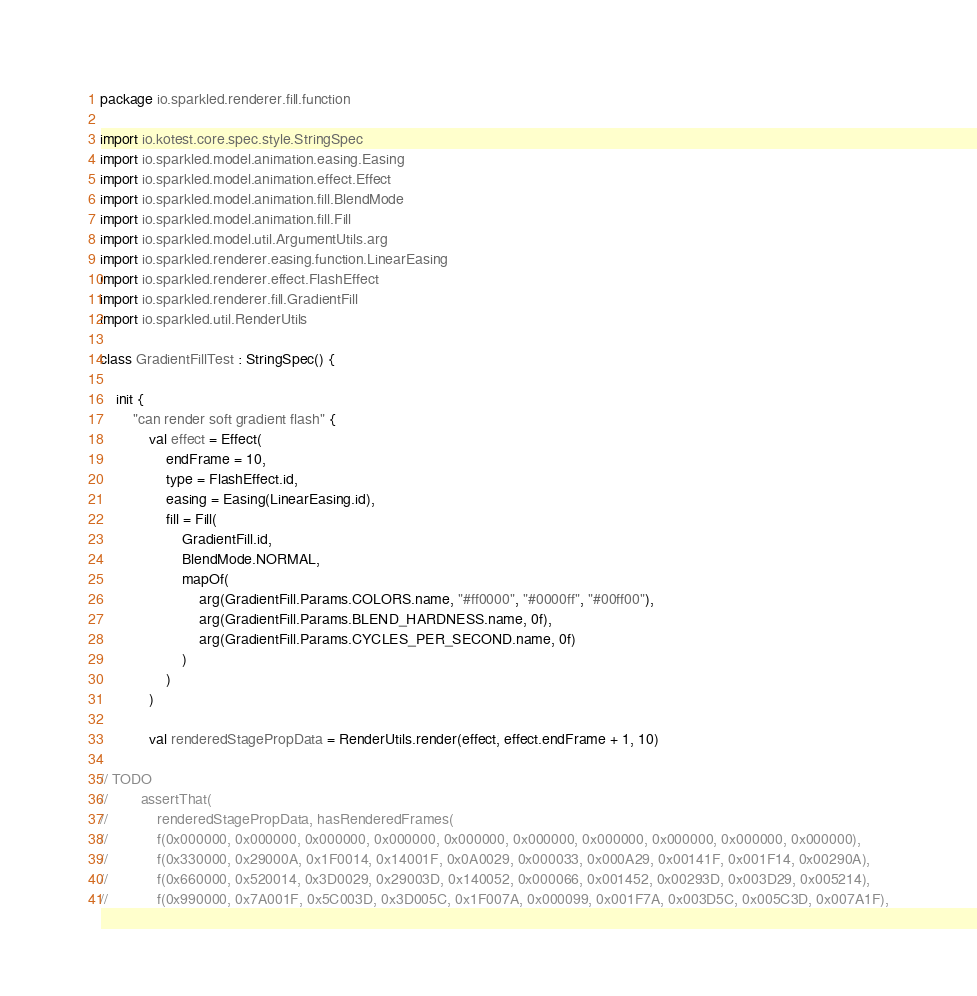<code> <loc_0><loc_0><loc_500><loc_500><_Kotlin_>package io.sparkled.renderer.fill.function

import io.kotest.core.spec.style.StringSpec
import io.sparkled.model.animation.easing.Easing
import io.sparkled.model.animation.effect.Effect
import io.sparkled.model.animation.fill.BlendMode
import io.sparkled.model.animation.fill.Fill
import io.sparkled.model.util.ArgumentUtils.arg
import io.sparkled.renderer.easing.function.LinearEasing
import io.sparkled.renderer.effect.FlashEffect
import io.sparkled.renderer.fill.GradientFill
import io.sparkled.util.RenderUtils

class GradientFillTest : StringSpec() {

    init {
        "can render soft gradient flash" {
            val effect = Effect(
                endFrame = 10,
                type = FlashEffect.id,
                easing = Easing(LinearEasing.id),
                fill = Fill(
                    GradientFill.id,
                    BlendMode.NORMAL,
                    mapOf(
                        arg(GradientFill.Params.COLORS.name, "#ff0000", "#0000ff", "#00ff00"),
                        arg(GradientFill.Params.BLEND_HARDNESS.name, 0f),
                        arg(GradientFill.Params.CYCLES_PER_SECOND.name, 0f)
                    )
                )
            )

            val renderedStagePropData = RenderUtils.render(effect, effect.endFrame + 1, 10)

// TODO
//        assertThat(
//            renderedStagePropData, hasRenderedFrames(
//            f(0x000000, 0x000000, 0x000000, 0x000000, 0x000000, 0x000000, 0x000000, 0x000000, 0x000000, 0x000000),
//            f(0x330000, 0x29000A, 0x1F0014, 0x14001F, 0x0A0029, 0x000033, 0x000A29, 0x00141F, 0x001F14, 0x00290A),
//            f(0x660000, 0x520014, 0x3D0029, 0x29003D, 0x140052, 0x000066, 0x001452, 0x00293D, 0x003D29, 0x005214),
//            f(0x990000, 0x7A001F, 0x5C003D, 0x3D005C, 0x1F007A, 0x000099, 0x001F7A, 0x003D5C, 0x005C3D, 0x007A1F),</code> 